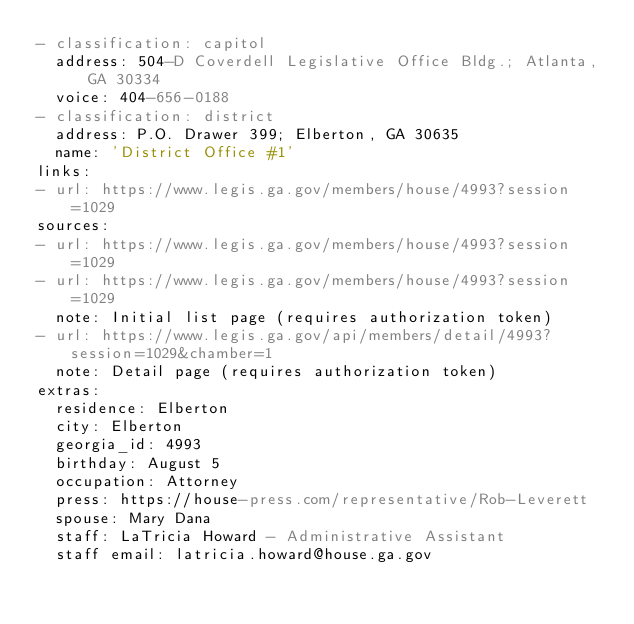Convert code to text. <code><loc_0><loc_0><loc_500><loc_500><_YAML_>- classification: capitol
  address: 504-D Coverdell Legislative Office Bldg.; Atlanta, GA 30334
  voice: 404-656-0188
- classification: district
  address: P.O. Drawer 399; Elberton, GA 30635
  name: 'District Office #1'
links:
- url: https://www.legis.ga.gov/members/house/4993?session=1029
sources:
- url: https://www.legis.ga.gov/members/house/4993?session=1029
- url: https://www.legis.ga.gov/members/house/4993?session=1029
  note: Initial list page (requires authorization token)
- url: https://www.legis.ga.gov/api/members/detail/4993?session=1029&chamber=1
  note: Detail page (requires authorization token)
extras:
  residence: Elberton
  city: Elberton
  georgia_id: 4993
  birthday: August 5
  occupation: Attorney
  press: https://house-press.com/representative/Rob-Leverett
  spouse: Mary Dana
  staff: LaTricia Howard - Administrative Assistant
  staff email: latricia.howard@house.ga.gov
</code> 